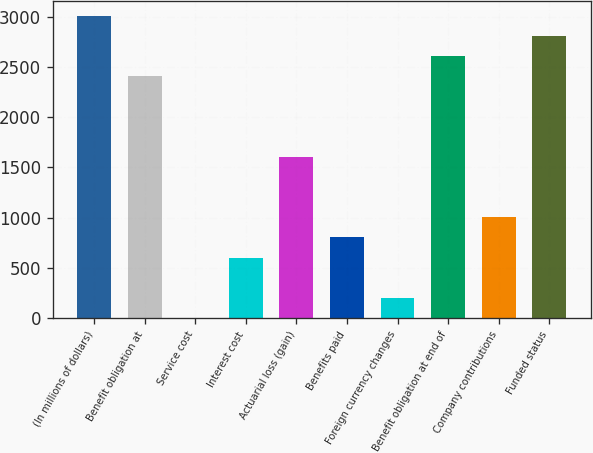<chart> <loc_0><loc_0><loc_500><loc_500><bar_chart><fcel>(In millions of dollars)<fcel>Benefit obligation at<fcel>Service cost<fcel>Interest cost<fcel>Actuarial loss (gain)<fcel>Benefits paid<fcel>Foreign currency changes<fcel>Benefit obligation at end of<fcel>Company contributions<fcel>Funded status<nl><fcel>3007<fcel>2405.8<fcel>1<fcel>602.2<fcel>1604.2<fcel>802.6<fcel>201.4<fcel>2606.2<fcel>1003<fcel>2806.6<nl></chart> 